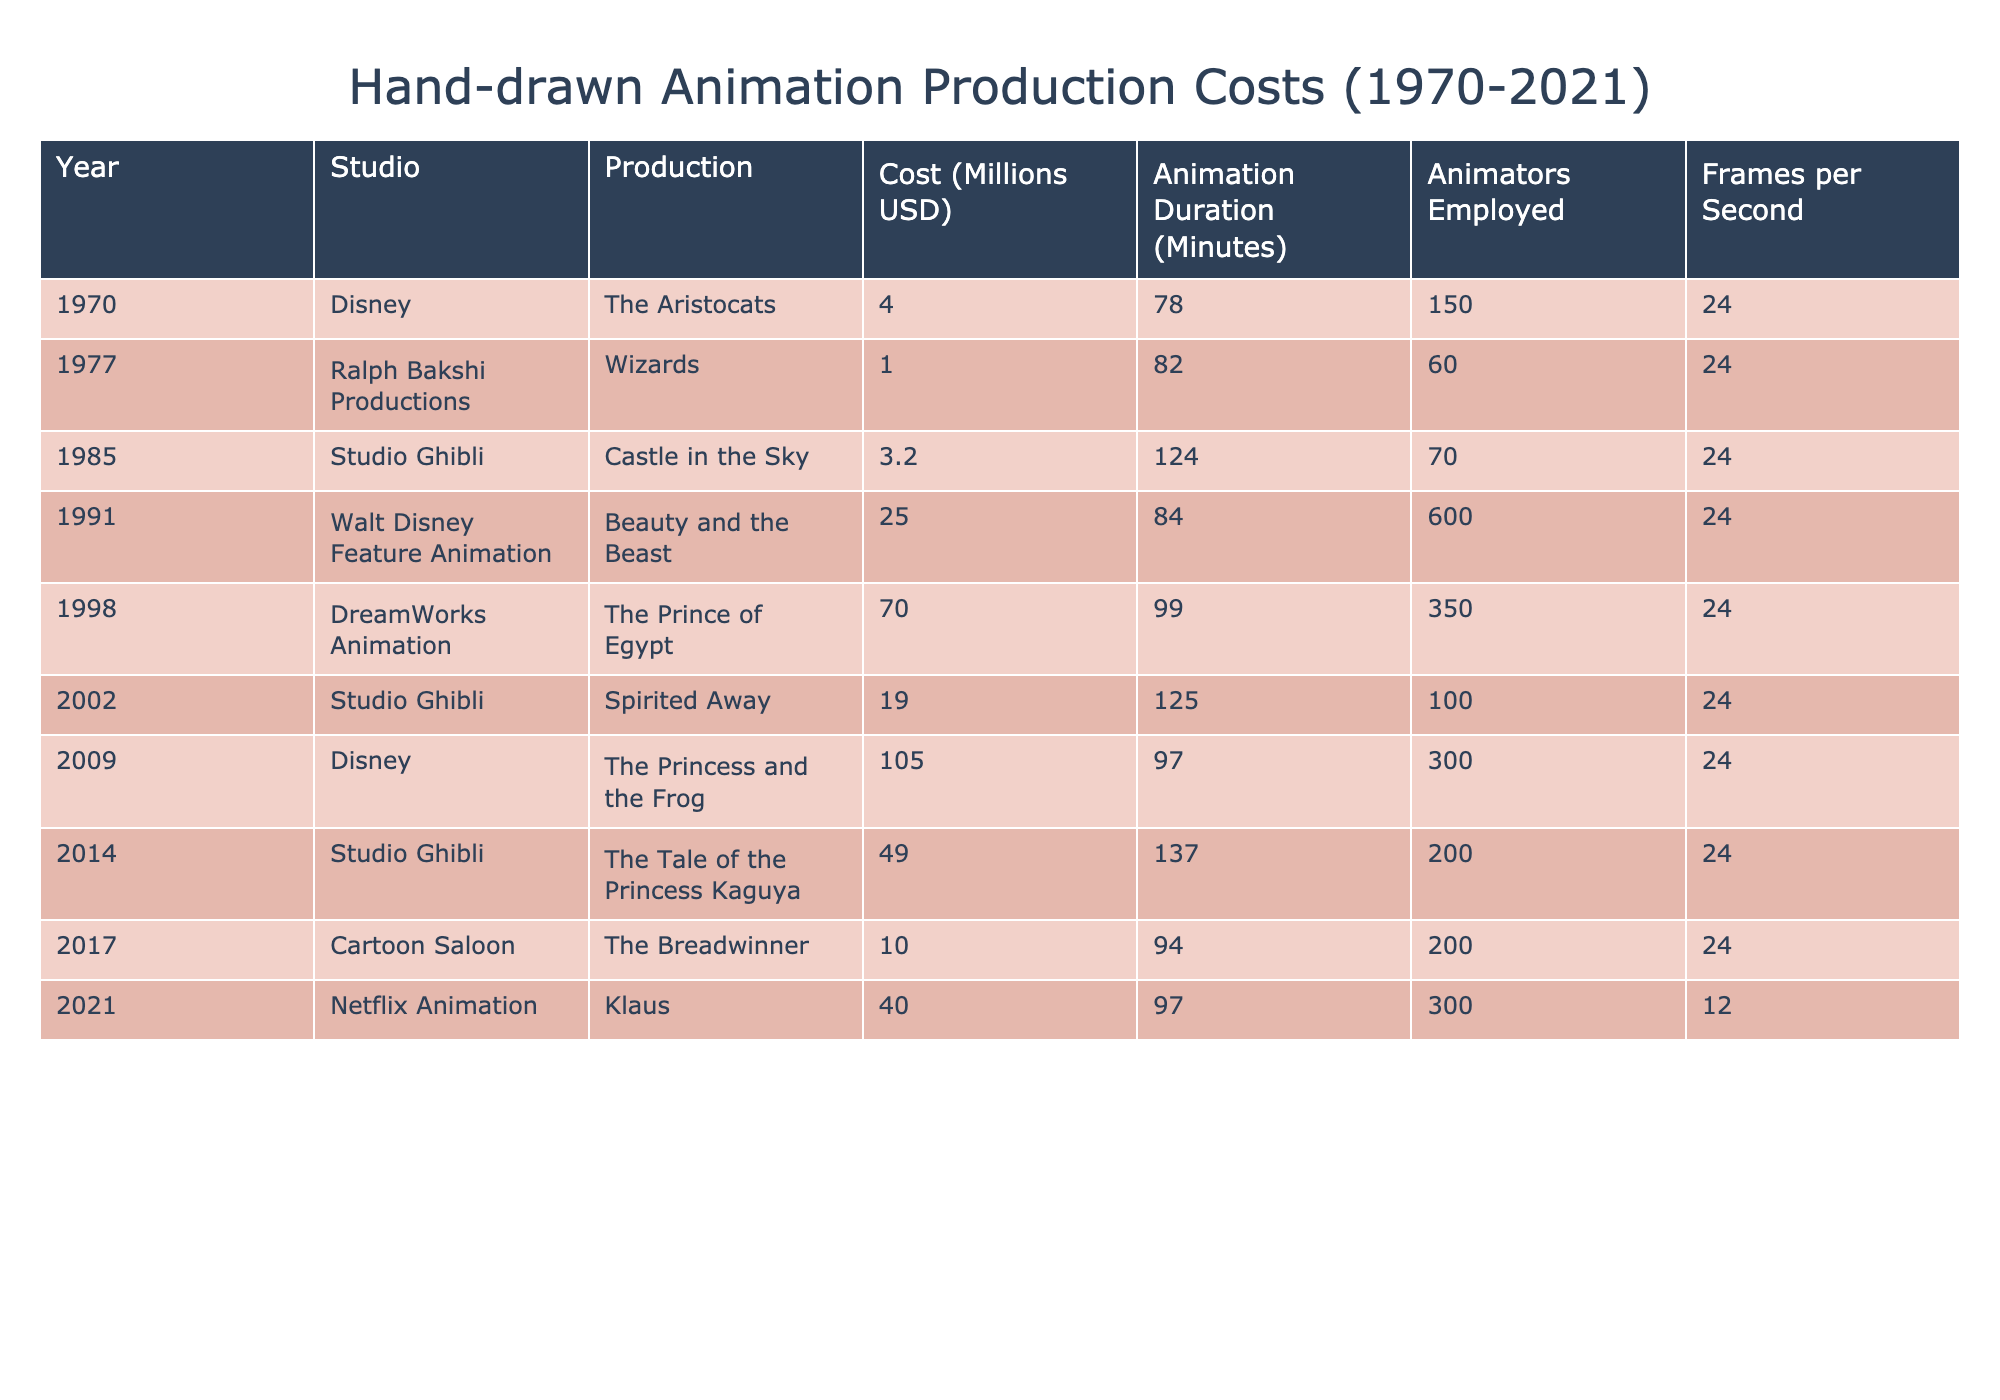What was the production cost of "The Breadwinner"? The table shows that "The Breadwinner" produced by Cartoon Saloon in 2017 had a production cost of 10 million USD.
Answer: 10 million USD Which animation had the highest cost of production? By comparing the production costs listed, "The Princess and the Frog" from Disney in 2009 has the highest cost at 105 million USD.
Answer: 105 million USD How many animators were employed for "Spirited Away"? The table indicates that "Spirited Away", produced by Studio Ghibli in 2002, employed 100 animators.
Answer: 100 animators What is the total production cost of all animations produced by Studio Ghibli? The productions by Studio Ghibli listed are "Castle in the Sky" (3.2 million), "Spirited Away" (19 million), and "The Tale of the Princess Kaguya" (49 million). Summing these, 3.2 + 19 + 49 = 71.2 million USD.
Answer: 71.2 million USD Was the average cost of animation production over the years increasing? To determine this, we calculate the average production cost from the table: (4 + 1 + 3.2 + 25 + 70 + 19 + 105 + 49 + 10 + 40) / 10 = 31.42 million USD. Furthermore, examining the costs over the years shows fluctuation, with significant increases noted in the later years. Thus, while not strictly linear, costs seem to trend upward in the recent years.
Answer: Yes, generally increasing What was the animation duration for "Beauty and the Beast"? Looking at the table, "Beauty and the Beast" produced by Walt Disney Feature Animation in 1991 had an animation duration of 84 minutes.
Answer: 84 minutes Which animation studio had the lowest production cost for an animated feature? The table shows that Ralph Bakshi Productions had the lowest production cost for "Wizards" in 1977, which was 1 million USD.
Answer: Ralph Bakshi Productions How many frames per second did "Klaus" have compared to other animations? The table shows that "Klaus" had 12 frames per second, while all other listed animations had 24 frames per second. Thus, "Klaus" had a significantly lower frame rate compared to the rest.
Answer: 12 frames per second Determine if the cost of "The Prince of Egypt" was greater than the average cost of the listed animations. We already calculated the average cost of all productions (31.42 million USD). "The Prince of Egypt" cost 70 million USD, which is greater than the average cost.
Answer: Yes, it was greater What was the total animation duration of films produced by Disney? The Disney films in the table are "The Aristocats" (78 minutes), "Beauty and the Beast" (84 minutes), and "The Princess and the Frog" (97 minutes). Summing these durations gives 78 + 84 + 97 = 259 minutes.
Answer: 259 minutes Which animation had the greatest number of animators employed, and how many were there? According to the data, "Beauty and the Beast" had the greatest number of animators employed, totaling 600 animators.
Answer: 600 animators 